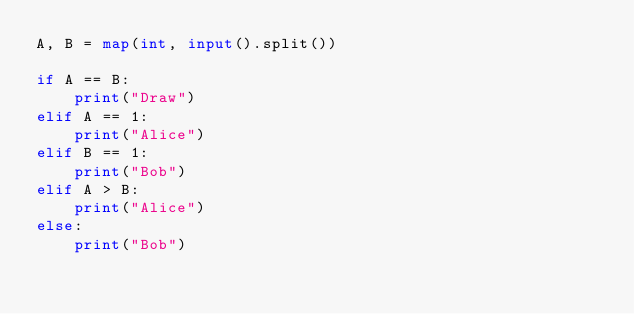Convert code to text. <code><loc_0><loc_0><loc_500><loc_500><_Python_>A, B = map(int, input().split())

if A == B:
    print("Draw")
elif A == 1:
    print("Alice")
elif B == 1:
    print("Bob")
elif A > B:
    print("Alice")
else:
    print("Bob")
</code> 